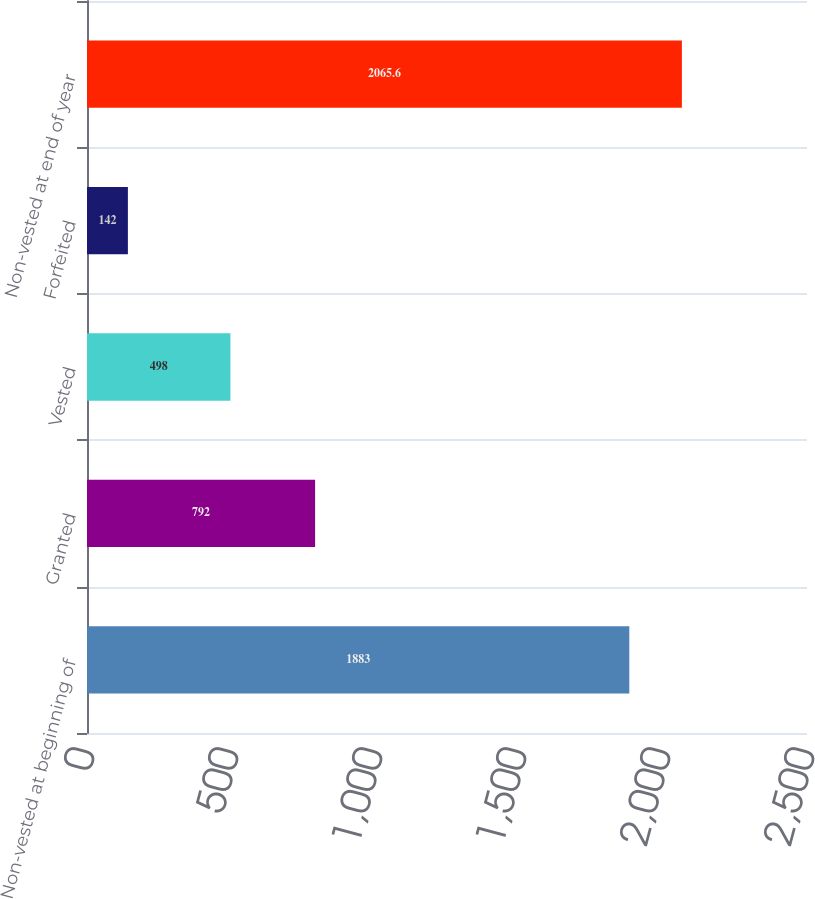Convert chart to OTSL. <chart><loc_0><loc_0><loc_500><loc_500><bar_chart><fcel>Non-vested at beginning of<fcel>Granted<fcel>Vested<fcel>Forfeited<fcel>Non-vested at end of year<nl><fcel>1883<fcel>792<fcel>498<fcel>142<fcel>2065.6<nl></chart> 